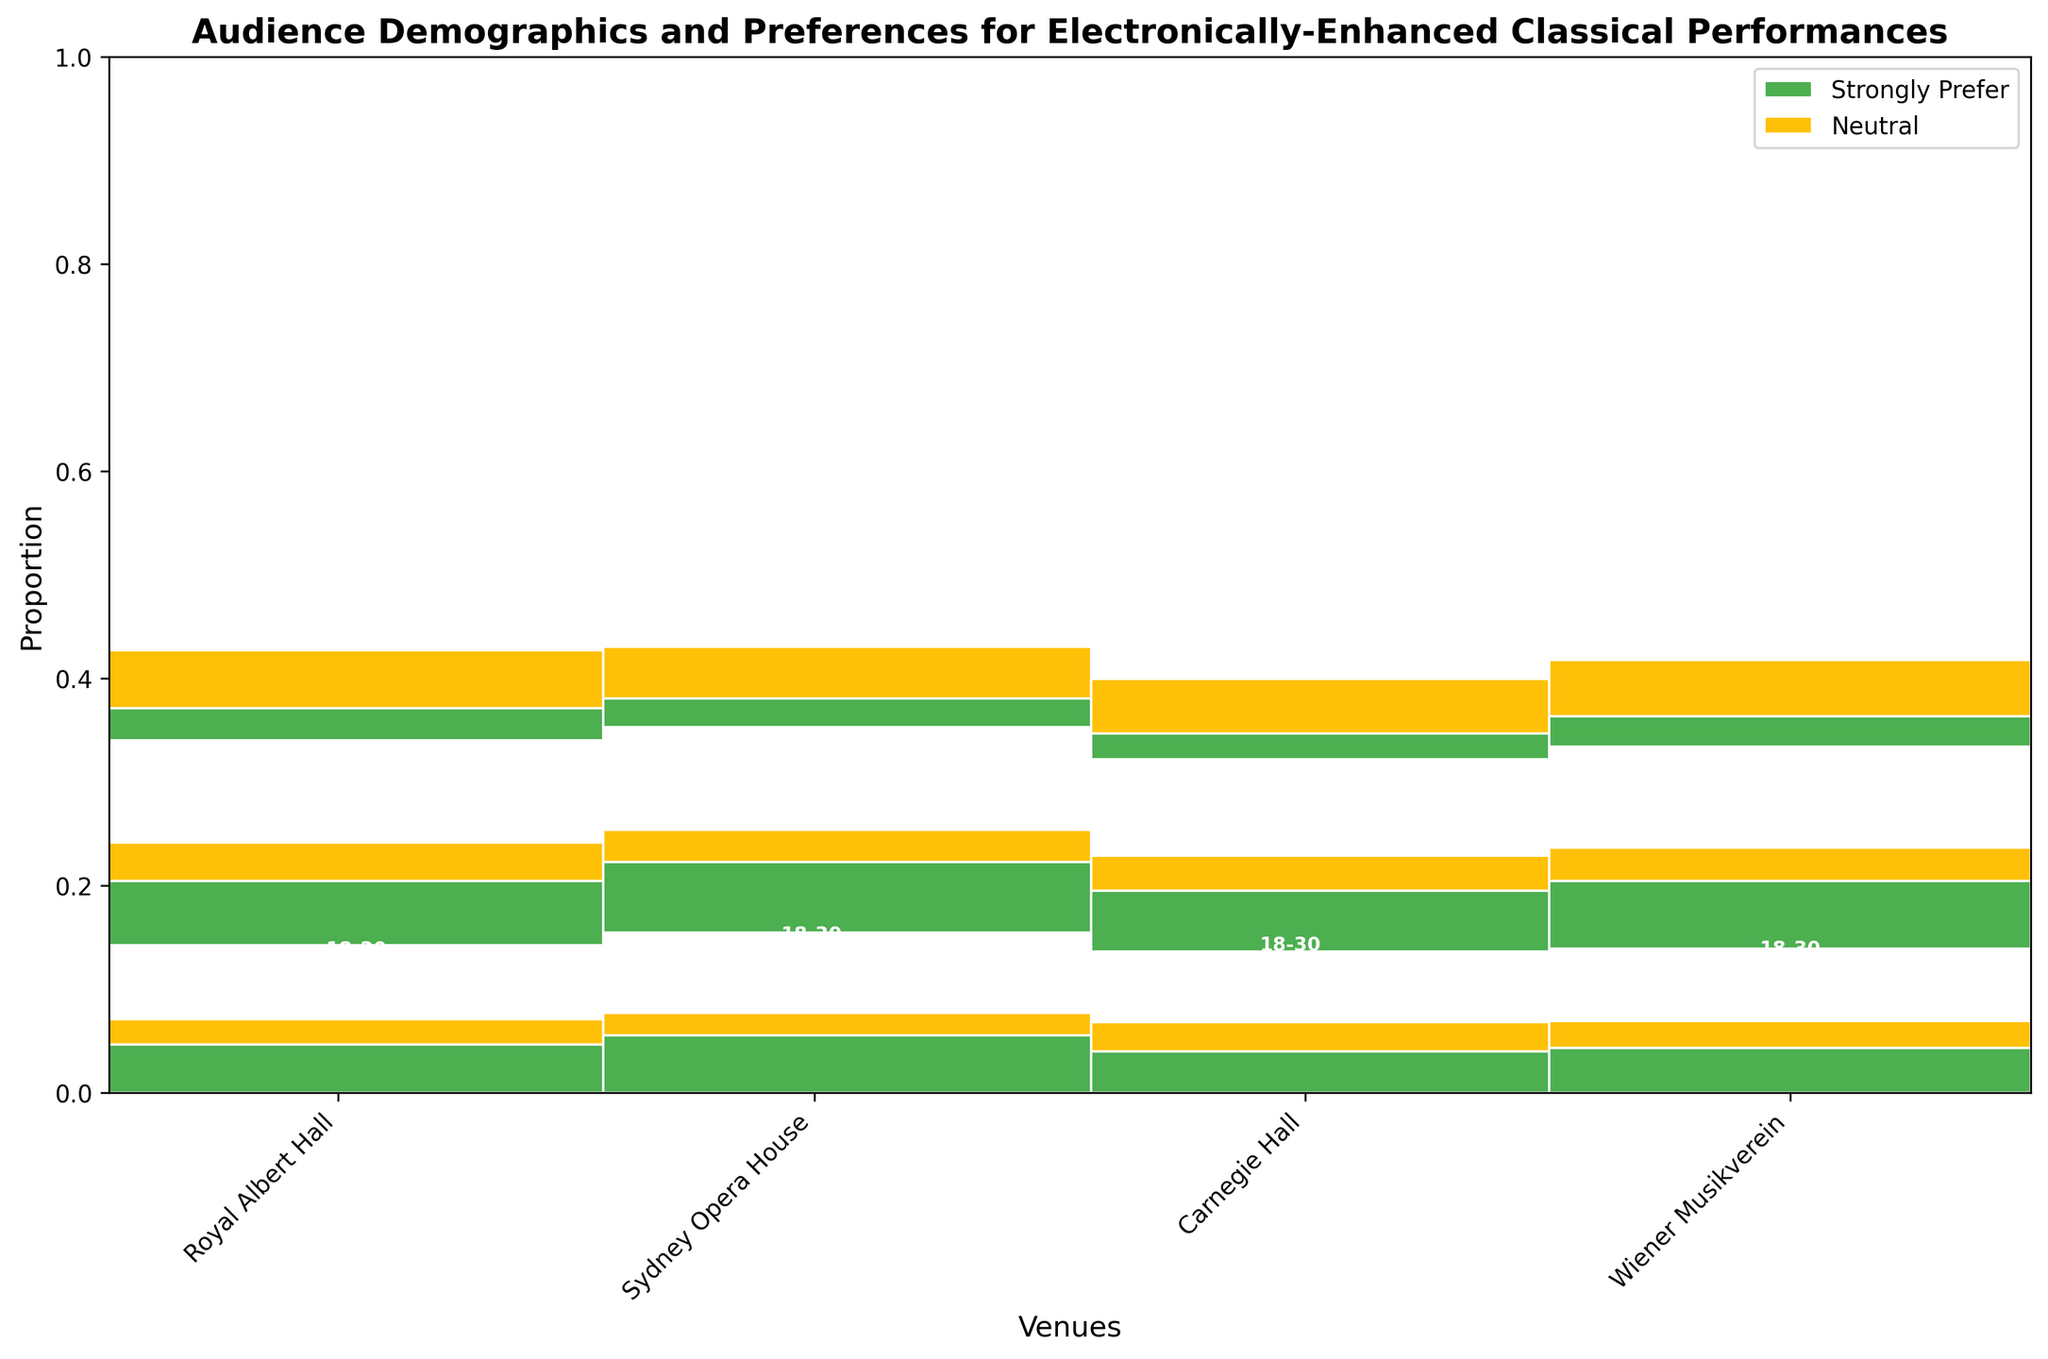What is the title of the figure? The title is typically displayed at the top of the figure.
Answer: Audience Demographics and Preferences for Electronically-Enhanced Classical Performances Which venue has the highest proportion of 18-30 age group who strongly prefer electronically-enhanced performances? By visually comparing the rectangles representing the 18-30 age group who strongly prefer in each venue, select the one with the largest area.
Answer: Sydney Opera House For Royal Albert Hall, does the 31-50 age group who strongly prefer electronically-enhanced performances have a larger proportion than the neutral preference for the same age group? Compare the height of the rectangles for the 31-50 age group in Royal Albert Hall for "Strongly Prefer" and "Neutral." The higher rectangle represents a larger proportion.
Answer: Yes Which venue has the smallest proportion of audience aged 51+ who strongly prefer electronically-enhanced performances? Identify the venue with the smallest height rectangle for the 51+ age group who strongly prefer electronically-enhanced compositions.
Answer: Carnegie Hall In which age group does Wiener Musikverein have the highest proportion of neutral preference? Compare the height of rectangles representing neutral preferences across the different age groups in Wiener Musikverein to find the tallest one.
Answer: 51+ Across all venues, which age group and preference combination is represented by the largest area? Calculate the rectangle areas across all venues, identifying the combination with the largest area.
Answer: 31-50, Strongly Prefer For Carnegie Hall, how does the proportion of the 18-30 age group who are neutral compare to the 51+ age group who are neutral? Compare the height of the rectangles for the 18-30 neutral and 51+ neutral preferences in Carnegie Hall.
Answer: The 51+ neutral group has a larger proportion Which venue has the largest overall proportion of audience members who strongly prefer electronically-enhanced classical performances? By comparing the total area for rectangles representing "Strongly Prefer" in all venues, find the one with the largest total.
Answer: Sydney Opera House Is there a venue where the proportion of the 31-50 age group strongly preferring electronically-enhanced performances is greater than 50% of that venue's total audience? Identify the height of the rectangle for the 31-50 strongly preferred group and ensure it occupies more than half the height of the total vertical space for one venue.
Answer: Yes, Royal Albert Hall 